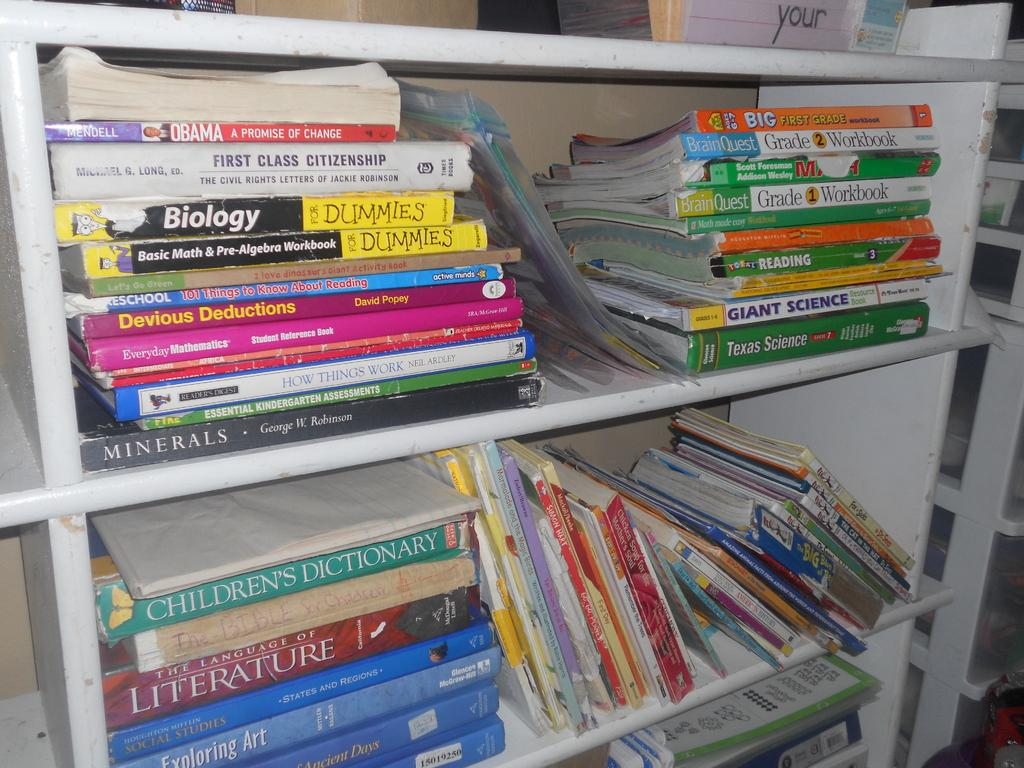What objects can be seen in the image? There are books in the image. How are the books organized in the image? The books are arranged in shelves. What type of snow can be seen falling on the books in the image? There is no snow present in the image; it features books arranged in shelves. 